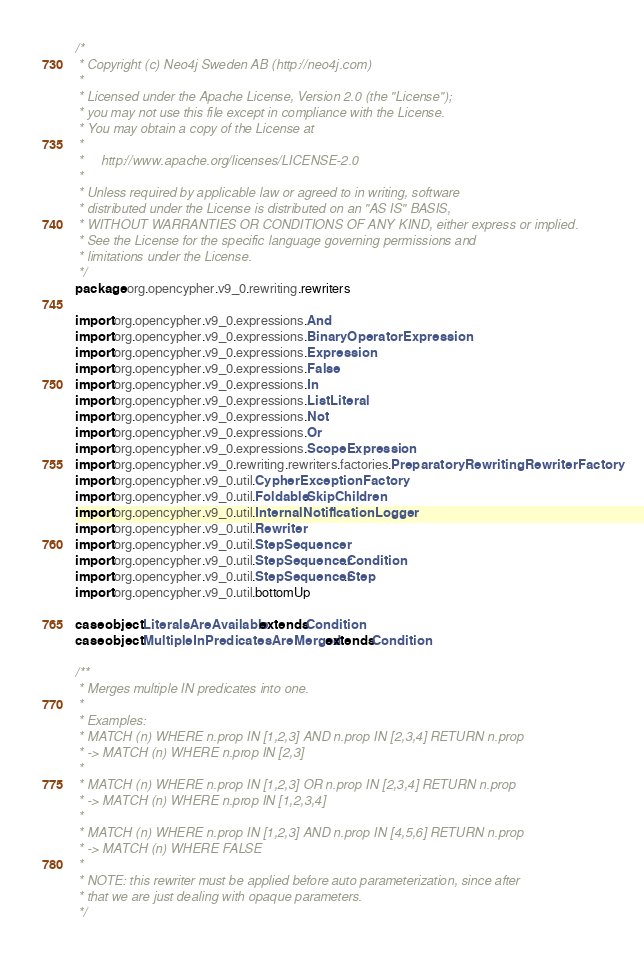<code> <loc_0><loc_0><loc_500><loc_500><_Scala_>/*
 * Copyright (c) Neo4j Sweden AB (http://neo4j.com)
 *
 * Licensed under the Apache License, Version 2.0 (the "License");
 * you may not use this file except in compliance with the License.
 * You may obtain a copy of the License at
 *
 *     http://www.apache.org/licenses/LICENSE-2.0
 *
 * Unless required by applicable law or agreed to in writing, software
 * distributed under the License is distributed on an "AS IS" BASIS,
 * WITHOUT WARRANTIES OR CONDITIONS OF ANY KIND, either express or implied.
 * See the License for the specific language governing permissions and
 * limitations under the License.
 */
package org.opencypher.v9_0.rewriting.rewriters

import org.opencypher.v9_0.expressions.And
import org.opencypher.v9_0.expressions.BinaryOperatorExpression
import org.opencypher.v9_0.expressions.Expression
import org.opencypher.v9_0.expressions.False
import org.opencypher.v9_0.expressions.In
import org.opencypher.v9_0.expressions.ListLiteral
import org.opencypher.v9_0.expressions.Not
import org.opencypher.v9_0.expressions.Or
import org.opencypher.v9_0.expressions.ScopeExpression
import org.opencypher.v9_0.rewriting.rewriters.factories.PreparatoryRewritingRewriterFactory
import org.opencypher.v9_0.util.CypherExceptionFactory
import org.opencypher.v9_0.util.Foldable.SkipChildren
import org.opencypher.v9_0.util.InternalNotificationLogger
import org.opencypher.v9_0.util.Rewriter
import org.opencypher.v9_0.util.StepSequencer
import org.opencypher.v9_0.util.StepSequencer.Condition
import org.opencypher.v9_0.util.StepSequencer.Step
import org.opencypher.v9_0.util.bottomUp

case object LiteralsAreAvailable extends Condition
case object MultipleInPredicatesAreMerged extends Condition

/**
 * Merges multiple IN predicates into one.
 *
 * Examples:
 * MATCH (n) WHERE n.prop IN [1,2,3] AND n.prop IN [2,3,4] RETURN n.prop
 * -> MATCH (n) WHERE n.prop IN [2,3]
 *
 * MATCH (n) WHERE n.prop IN [1,2,3] OR n.prop IN [2,3,4] RETURN n.prop
 * -> MATCH (n) WHERE n.prop IN [1,2,3,4]
 *
 * MATCH (n) WHERE n.prop IN [1,2,3] AND n.prop IN [4,5,6] RETURN n.prop
 * -> MATCH (n) WHERE FALSE
 *
 * NOTE: this rewriter must be applied before auto parameterization, since after
 * that we are just dealing with opaque parameters.
 */</code> 